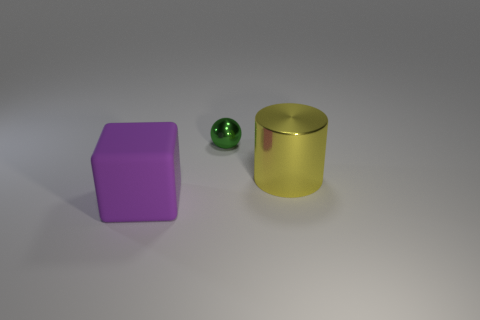How would you describe the lighting in this scene? The lighting appears diffused, with soft shadows around the objects, suggesting an indirect light source. There is no harsh shadow, indicating a well-lit, evenly illuminated scene. 